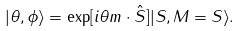Convert formula to latex. <formula><loc_0><loc_0><loc_500><loc_500>| \theta , \phi \rangle = \exp [ i \theta { m } \cdot \hat { S } ] | S , M = S \rangle .</formula> 